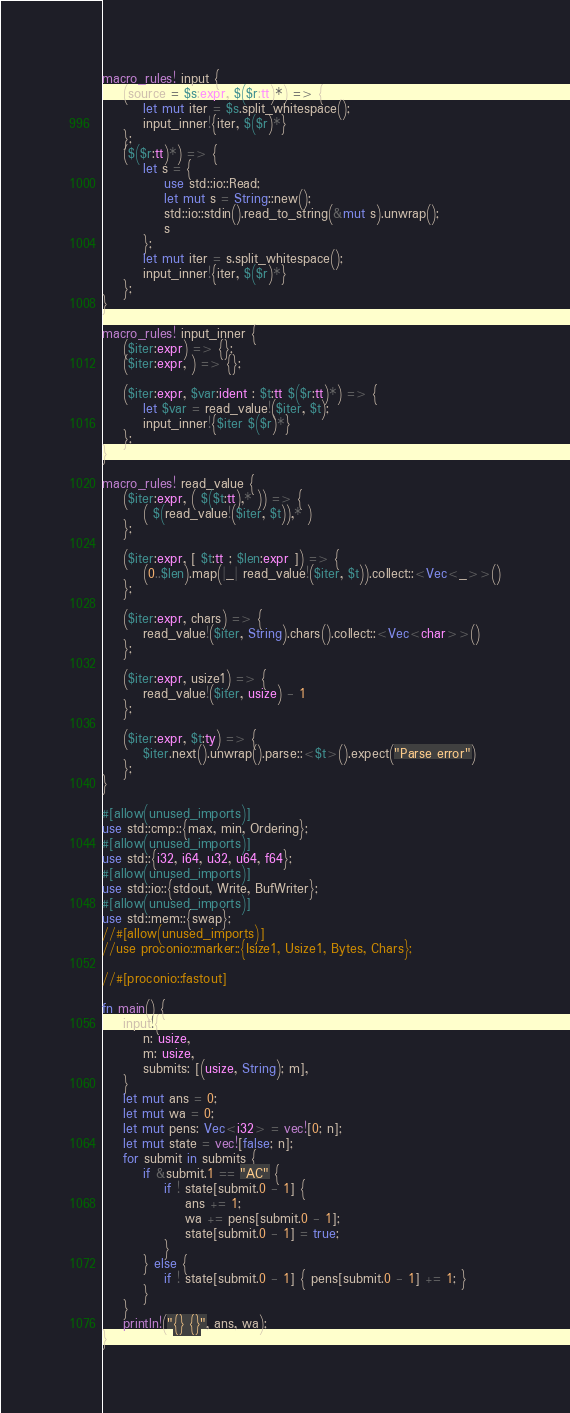<code> <loc_0><loc_0><loc_500><loc_500><_Rust_>macro_rules! input {
    (source = $s:expr, $($r:tt)*) => {
        let mut iter = $s.split_whitespace();
        input_inner!{iter, $($r)*}
    };
    ($($r:tt)*) => {
        let s = {
            use std::io::Read;
            let mut s = String::new();
            std::io::stdin().read_to_string(&mut s).unwrap();
            s
        };
        let mut iter = s.split_whitespace();
        input_inner!{iter, $($r)*}
    };
}

macro_rules! input_inner {
    ($iter:expr) => {};
    ($iter:expr, ) => {};

    ($iter:expr, $var:ident : $t:tt $($r:tt)*) => {
        let $var = read_value!($iter, $t);
        input_inner!{$iter $($r)*}
    };
}

macro_rules! read_value {
    ($iter:expr, ( $($t:tt),* )) => {
        ( $(read_value!($iter, $t)),* )
    };

    ($iter:expr, [ $t:tt ; $len:expr ]) => {
        (0..$len).map(|_| read_value!($iter, $t)).collect::<Vec<_>>()
    };

    ($iter:expr, chars) => {
        read_value!($iter, String).chars().collect::<Vec<char>>()
    };

    ($iter:expr, usize1) => {
        read_value!($iter, usize) - 1
    };

    ($iter:expr, $t:ty) => {
        $iter.next().unwrap().parse::<$t>().expect("Parse error")
    };
}

#[allow(unused_imports)]
use std::cmp::{max, min, Ordering};
#[allow(unused_imports)]
use std::{i32, i64, u32, u64, f64};
#[allow(unused_imports)]
use std::io::{stdout, Write, BufWriter};
#[allow(unused_imports)]
use std::mem::{swap};
//#[allow(unused_imports)]
//use proconio::marker::{Isize1, Usize1, Bytes, Chars};

//#[proconio::fastout]

fn main() {
    input!{
        n: usize,
        m: usize,
        submits: [(usize, String); m],
    }
    let mut ans = 0;
    let mut wa = 0;
    let mut pens: Vec<i32> = vec![0; n];
    let mut state = vec![false; n];
    for submit in submits {
        if &submit.1 == "AC" {
            if ! state[submit.0 - 1] {
                ans += 1;
                wa += pens[submit.0 - 1];
                state[submit.0 - 1] = true;
            }
        } else {
            if ! state[submit.0 - 1] { pens[submit.0 - 1] += 1; }
        }
    }
    println!("{} {}", ans, wa);
}

</code> 